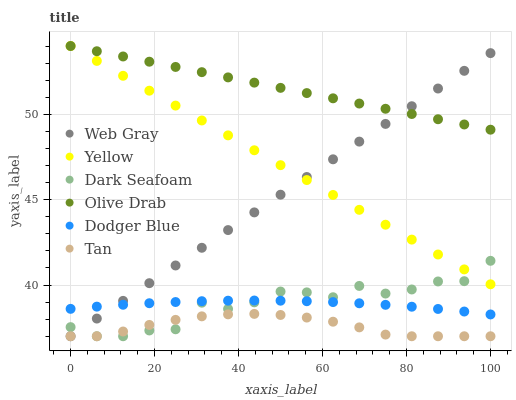Does Tan have the minimum area under the curve?
Answer yes or no. Yes. Does Olive Drab have the maximum area under the curve?
Answer yes or no. Yes. Does Yellow have the minimum area under the curve?
Answer yes or no. No. Does Yellow have the maximum area under the curve?
Answer yes or no. No. Is Olive Drab the smoothest?
Answer yes or no. Yes. Is Dark Seafoam the roughest?
Answer yes or no. Yes. Is Yellow the smoothest?
Answer yes or no. No. Is Yellow the roughest?
Answer yes or no. No. Does Web Gray have the lowest value?
Answer yes or no. Yes. Does Yellow have the lowest value?
Answer yes or no. No. Does Olive Drab have the highest value?
Answer yes or no. Yes. Does Dark Seafoam have the highest value?
Answer yes or no. No. Is Dodger Blue less than Yellow?
Answer yes or no. Yes. Is Olive Drab greater than Dark Seafoam?
Answer yes or no. Yes. Does Yellow intersect Olive Drab?
Answer yes or no. Yes. Is Yellow less than Olive Drab?
Answer yes or no. No. Is Yellow greater than Olive Drab?
Answer yes or no. No. Does Dodger Blue intersect Yellow?
Answer yes or no. No. 